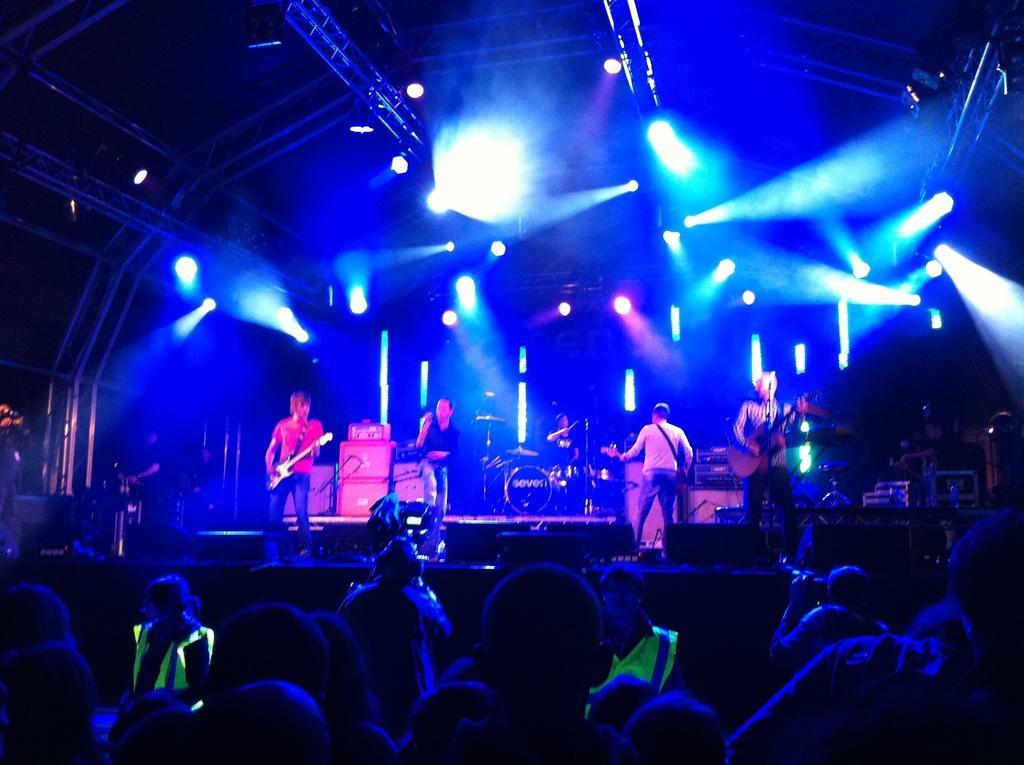Could you give a brief overview of what you see in this image? In this picture there are people at the bottom side of the image and there is a stage in the center of the image, there is a drum set in the center of the image on the stage and there are men on the stage, by holding guitars in their hands and there are spotlights on the roof. 